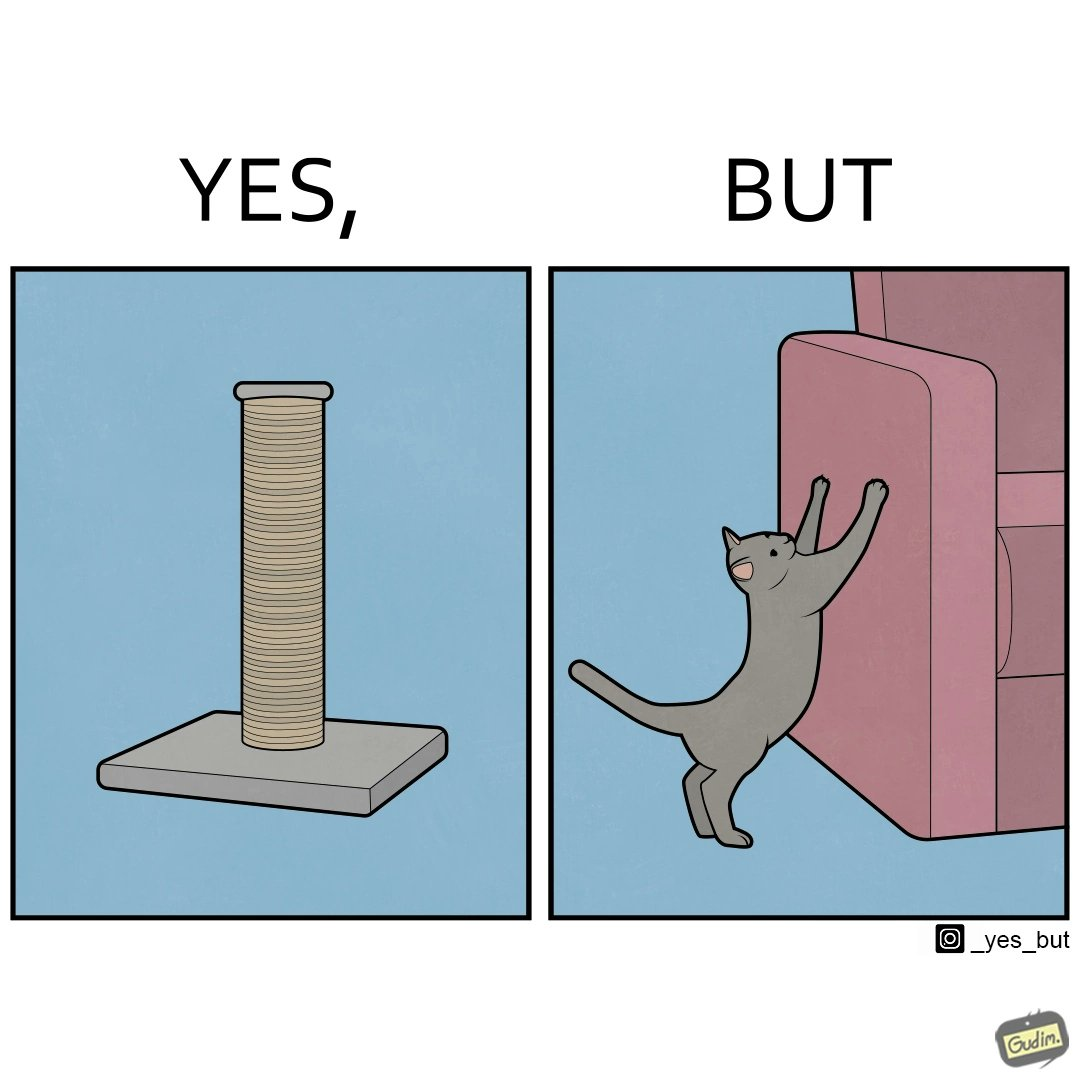What does this image depict? The image is ironic, because in the first image a toy, purposed for the cat to play with is shown but in the second image the cat is comfortably enjoying  to play on the sides of sofa 